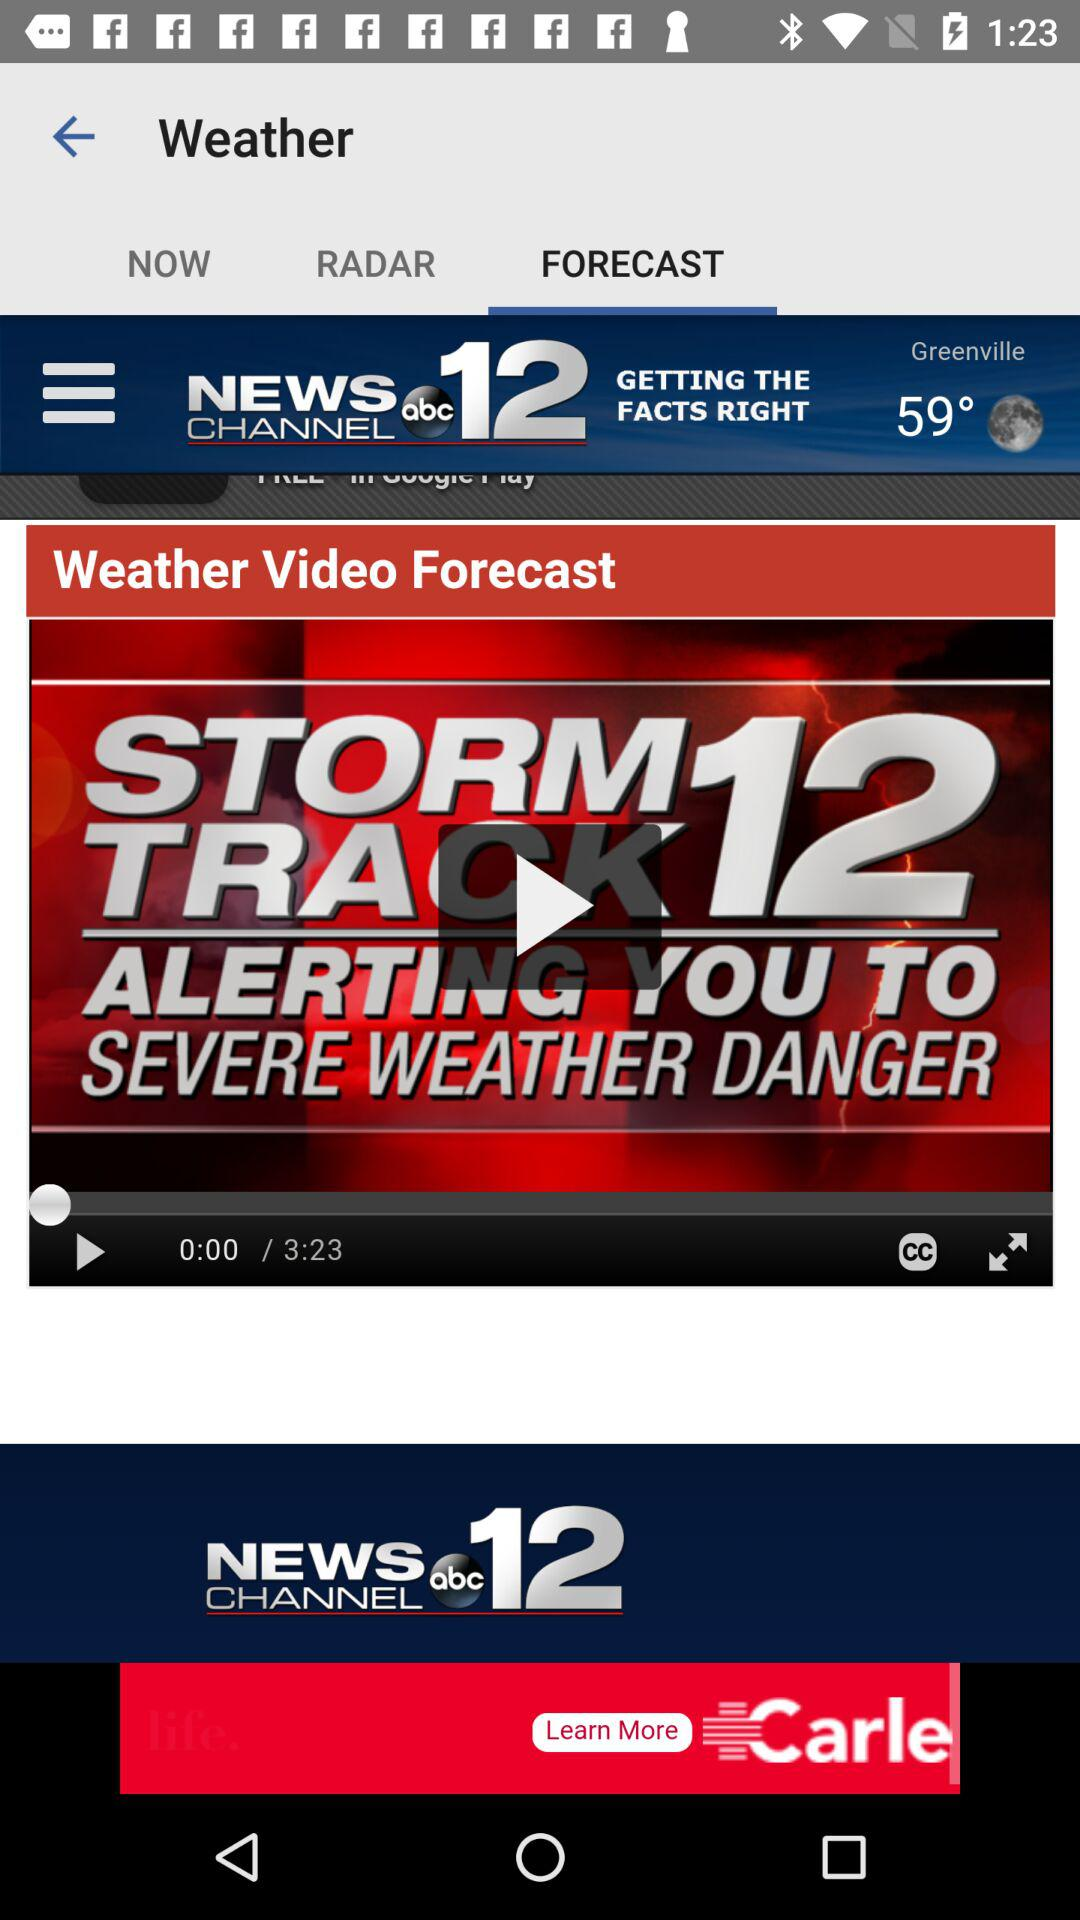How is the weather in Greenville?
When the provided information is insufficient, respond with <no answer>. <no answer> 